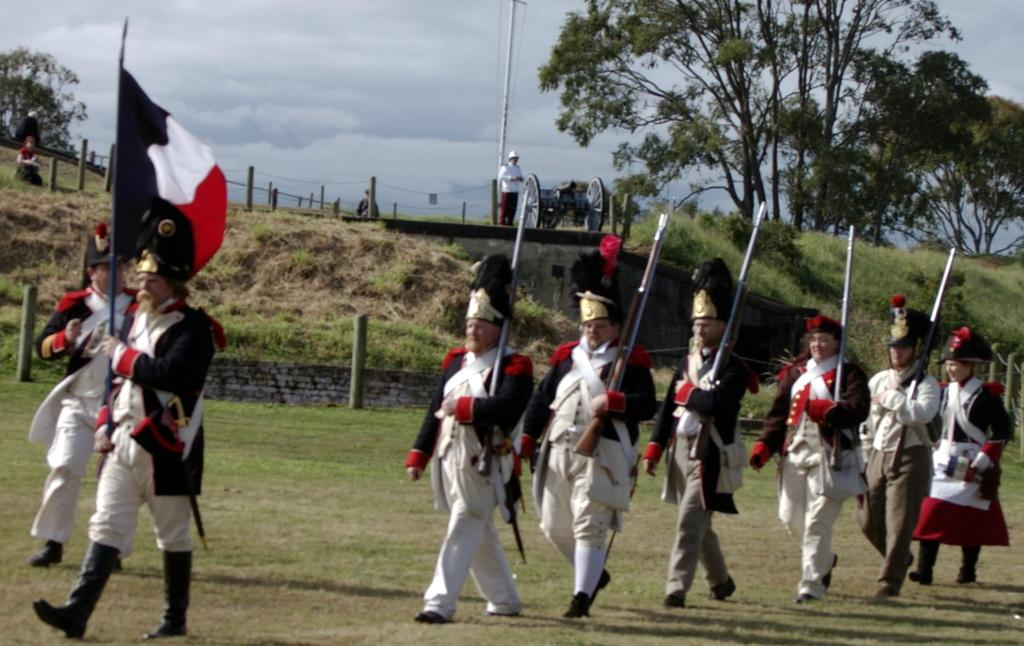What are the people in the image doing? The people in the image are walking. How can you describe the clothing of the people in the image? The people are wearing different color dresses. What are the people holding in the image? The people are holding something, but the facts do not specify what they are holding. What can be seen in the background of the image? There are trees, a vehicle, poles, and the sky visible in the background. What is the color of the sky in the image? The sky appears to be white in the image. How does the glove help the people in the image gain knowledge? There is no glove present in the image, so it cannot help the people gain knowledge. 